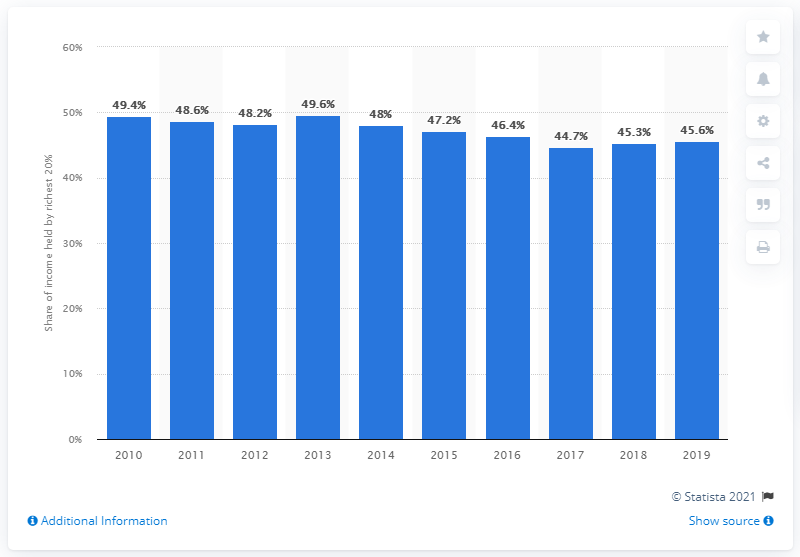Point out several critical features in this image. In 2017, the richest 20 percent of El Salvador's population held 44.7 percent of the country's total income. In 2019, the richest 20 percent of El Salvador's population held 45.6 percent of the country's total income. 